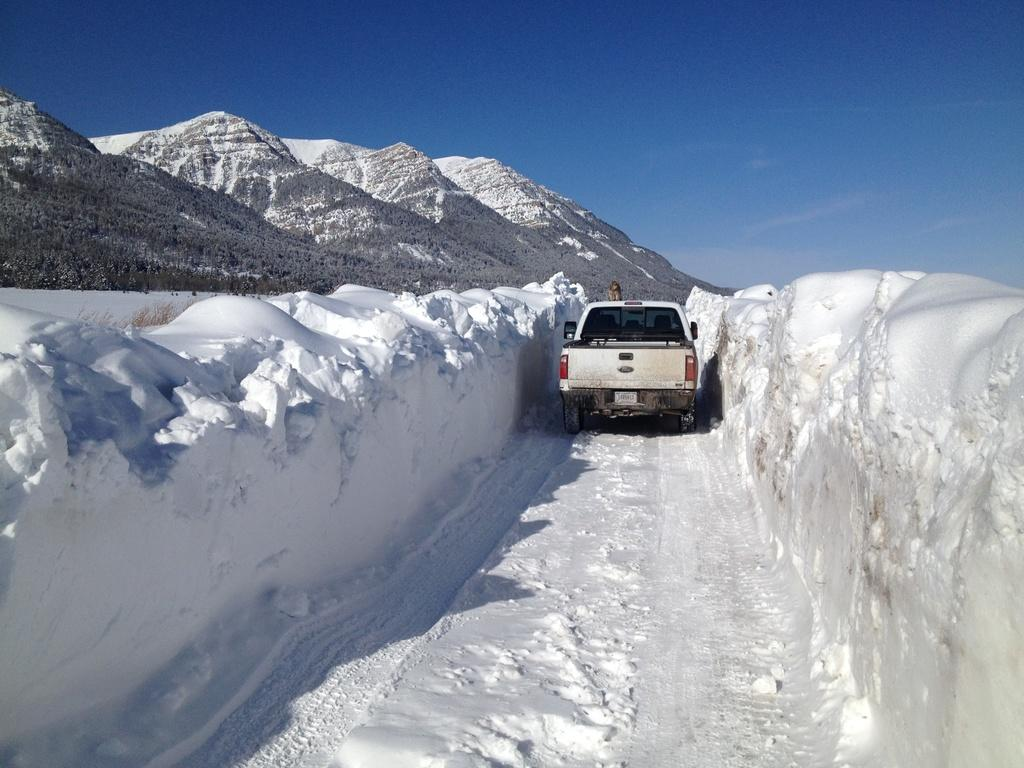What is the overall appearance of the image? The image is covered in snow. What can be seen on the ground in the image? There is a path in the image. What type of vehicle is present in the image? There is a vehicle in the image. What geographical feature is visible on the left side of the image? There are mountains on the left side of the image. What part of the natural environment is visible in the image? The sky is visible in the image. What type of love can be seen exchanged between the band members in the image? There is no band or exchange of love present in the image; it features a snowy landscape with a path, vehicle, mountains, and sky. 